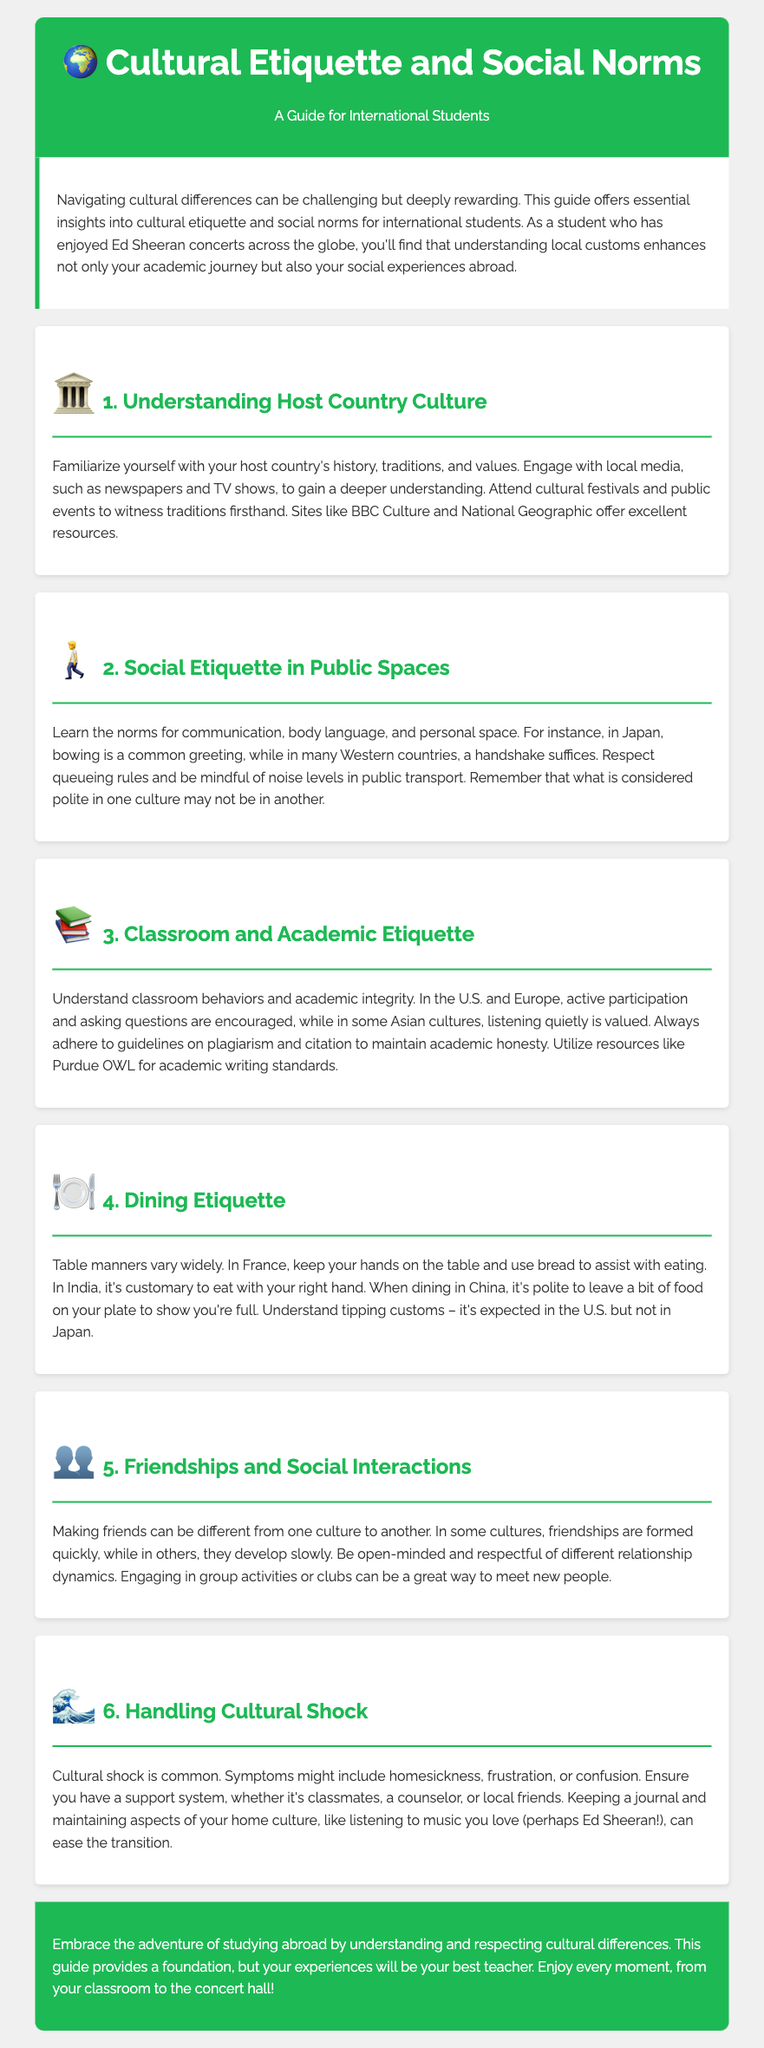what is the title of the guide? The title of the guide is presented prominently at the top of the document.
Answer: Cultural Etiquette and Social Norms what is the first section of the guide about? The first section explains the importance of understanding the host country's culture, including history and traditions.
Answer: Understanding Host Country Culture which country is mentioned in relation to greeting customs? The document references a specific country associated with particular greeting customs as an example.
Answer: Japan what is a common symptom of cultural shock? The guide lists symptoms that international students might experience while adapting to a new culture.
Answer: Homesickness what is the purpose of engaging in group activities according to the guide? The guide suggests participating in group activities for a specific reason beneficial to international students.
Answer: Meeting new people how should one eat in India according to the dining etiquette? The document provides specific guidance on dining customs in different cultures, particularly mentioning India.
Answer: With your right hand what resource is mentioned for academic writing standards? The guide refers to a specific source to help students with academic integrity and writing.
Answer: Purdue OWL what is emphasized as a tool for handling cultural shock? The document suggests a practical strategy to cope with cultural shock that involves reflecting on personal experiences.
Answer: Keeping a journal how does the guide suggest maintaining ties to one's home culture? The guide encourages international students to keep certain aspects of their home culture alive during their studies abroad.
Answer: Listening to music 